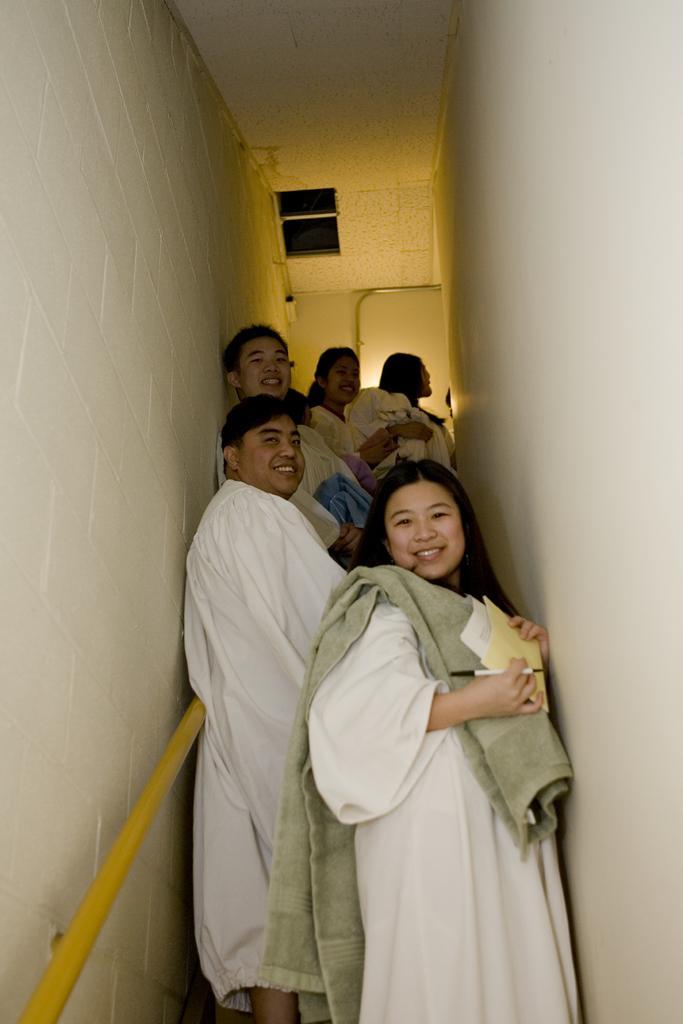How would you summarize this image in a sentence or two? In this image few people are standing on the staircase. A woman is holding a pen and few papers in her hand. She is wearing a cloth on her shoulder. Left side there is a metal rod attached to the wall. 